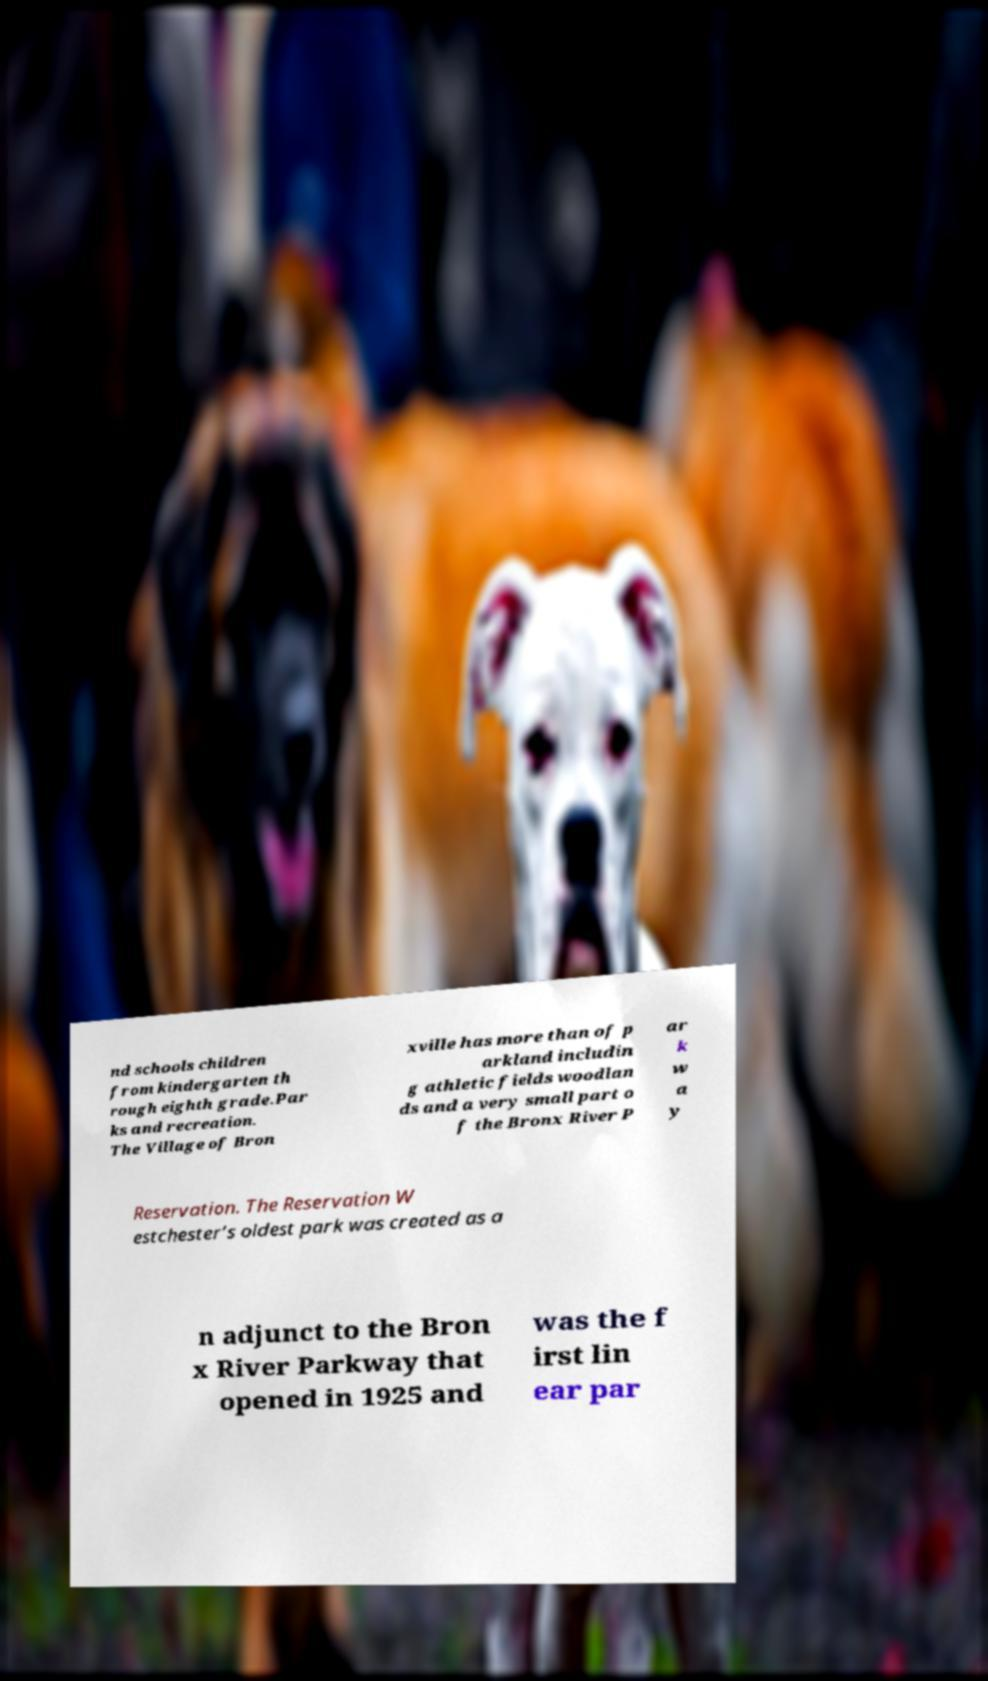Could you extract and type out the text from this image? nd schools children from kindergarten th rough eighth grade.Par ks and recreation. The Village of Bron xville has more than of p arkland includin g athletic fields woodlan ds and a very small part o f the Bronx River P ar k w a y Reservation. The Reservation W estchester’s oldest park was created as a n adjunct to the Bron x River Parkway that opened in 1925 and was the f irst lin ear par 